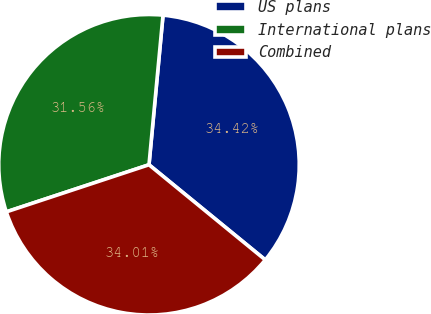Convert chart to OTSL. <chart><loc_0><loc_0><loc_500><loc_500><pie_chart><fcel>US plans<fcel>International plans<fcel>Combined<nl><fcel>34.42%<fcel>31.56%<fcel>34.01%<nl></chart> 